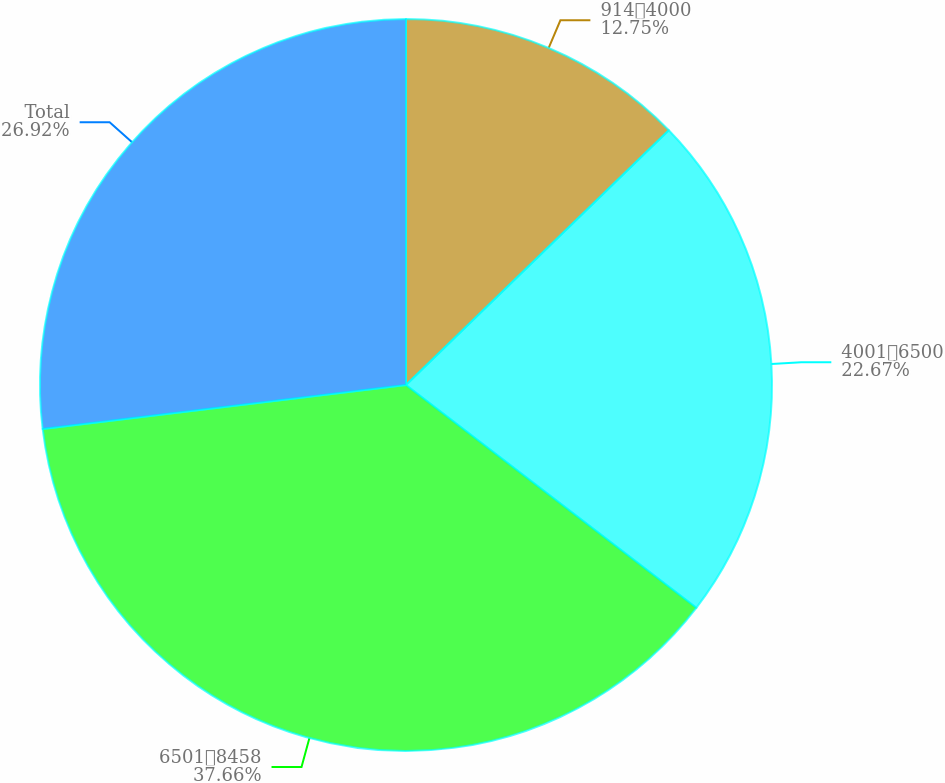<chart> <loc_0><loc_0><loc_500><loc_500><pie_chart><fcel>9144000<fcel>40016500<fcel>65018458<fcel>Total<nl><fcel>12.75%<fcel>22.67%<fcel>37.67%<fcel>26.92%<nl></chart> 